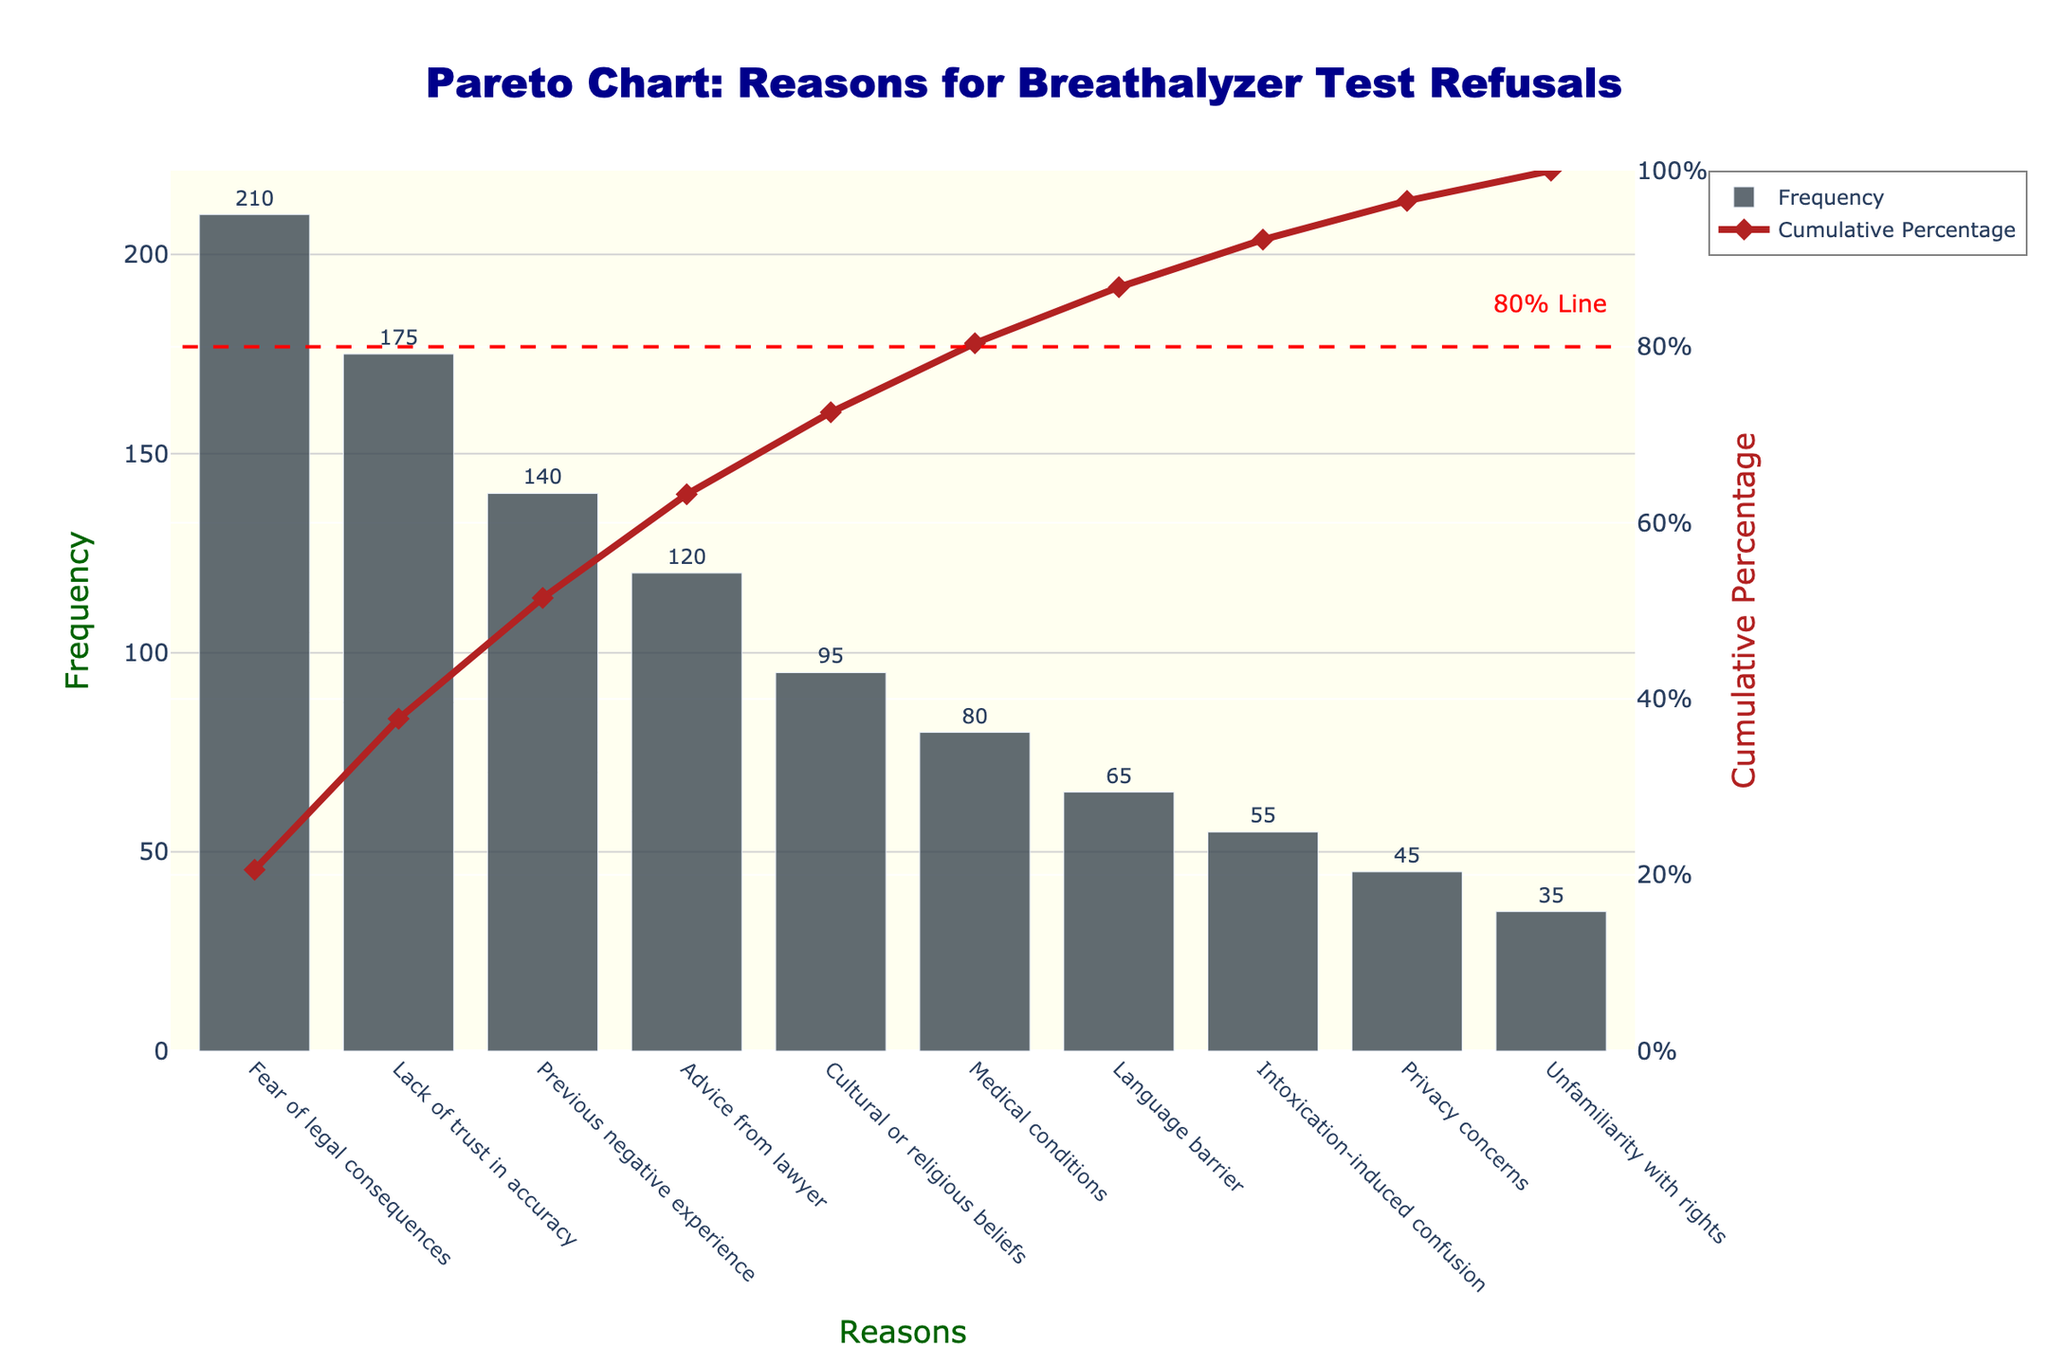What is the most common reason drivers refuse breathalyzer tests according to the chart? The chart shows the frequency of different reasons for refusing breathalyzer tests, with the tallest bar representing the most common reason. The tallest bar is labeled "Fear of legal consequences."
Answer: Fear of legal consequences What cumulative percentage does the "Lack of trust in accuracy" category contribute to? The bar for "Lack of trust in accuracy" is followed by a diamond marker on the cumulative percentage line, indicating the cumulative percentage up to that point. This figure shows the cumulative percentage for "Lack of trust in accuracy" as 50%.
Answer: 50% Compare the frequency of "Medical conditions" and "Language barrier." Which reason is more common? The bar for "Medical conditions" is taller than the bar for "Language barrier," indicating that "Medical conditions" occur more frequently than "Language barrier."
Answer: Medical conditions How many reasons contribute to achieving 80% of the cumulative percentage? The horizontal dashed line at 80% intersects the cumulative percentage line. Counting up to this intersection point, the bars for the first 6 reasons ("Fear of legal consequences," "Lack of trust in accuracy," "Previous negative experience," "Advice from lawyer," "Cultural or religious beliefs," and "Medical conditions") account for 80% of the cumulative percentage.
Answer: 6 What is the total frequency of drivers citing "Advice from lawyer" and "Cultural or religious beliefs"? The frequency for "Advice from lawyer" is 120 and for "Cultural or religious beliefs" is 95. Summing these gives 120 + 95 = 215.
Answer: 215 What is the frequency difference between "Previous negative experience" and "Privacy concerns"? The frequency of "Previous negative experience" is 140 and "Privacy concerns" is 45. The difference is 140 - 45 = 95.
Answer: 95 Which is less frequent: "Intoxication-induced confusion" or "Unfamiliarity with rights"? The bar for "Unfamiliarity with rights" is smaller than the bar for "Intoxication-induced confusion," which means "Unfamiliarity with rights" is less frequent.
Answer: Unfamiliarity with rights What is the cumulative percentage after including the "Previous negative experience" category? The cumulative percentage after "Previous negative experience" includes the first three categories: "Fear of legal consequences," "Lack of trust in accuracy," and "Previous negative experience." This cumulative percentage is 70%.
Answer: 70% Which category has a frequency of 55? The height of the bar for "Intoxication-induced confusion" corresponds to a frequency of 55, as indicated by the text label above the bar.
Answer: Intoxication-induced confusion 